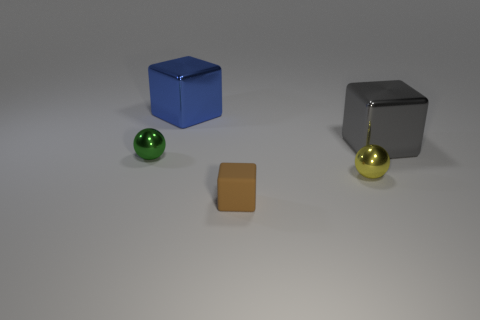Are there fewer big gray objects that are behind the blue shiny thing than large blue things that are in front of the small brown cube?
Provide a succinct answer. No. There is a thing that is both in front of the green sphere and behind the tiny brown rubber block; how big is it?
Provide a succinct answer. Small. Are there any big gray cubes on the left side of the block in front of the tiny object that is to the left of the brown thing?
Ensure brevity in your answer.  No. Is there a brown matte cylinder?
Keep it short and to the point. No. Is the number of small matte things on the left side of the tiny yellow metal ball greater than the number of tiny brown blocks on the right side of the brown matte object?
Offer a very short reply. Yes. What size is the green sphere that is made of the same material as the blue thing?
Your response must be concise. Small. There is a sphere that is to the left of the small metallic thing in front of the small shiny ball that is on the left side of the large blue block; how big is it?
Provide a succinct answer. Small. There is a small ball left of the small matte thing; what is its color?
Your answer should be compact. Green. Is the number of tiny green shiny spheres to the right of the small rubber thing greater than the number of red balls?
Make the answer very short. No. There is a small metallic object that is left of the small brown thing; is its shape the same as the gray thing?
Offer a very short reply. No. 